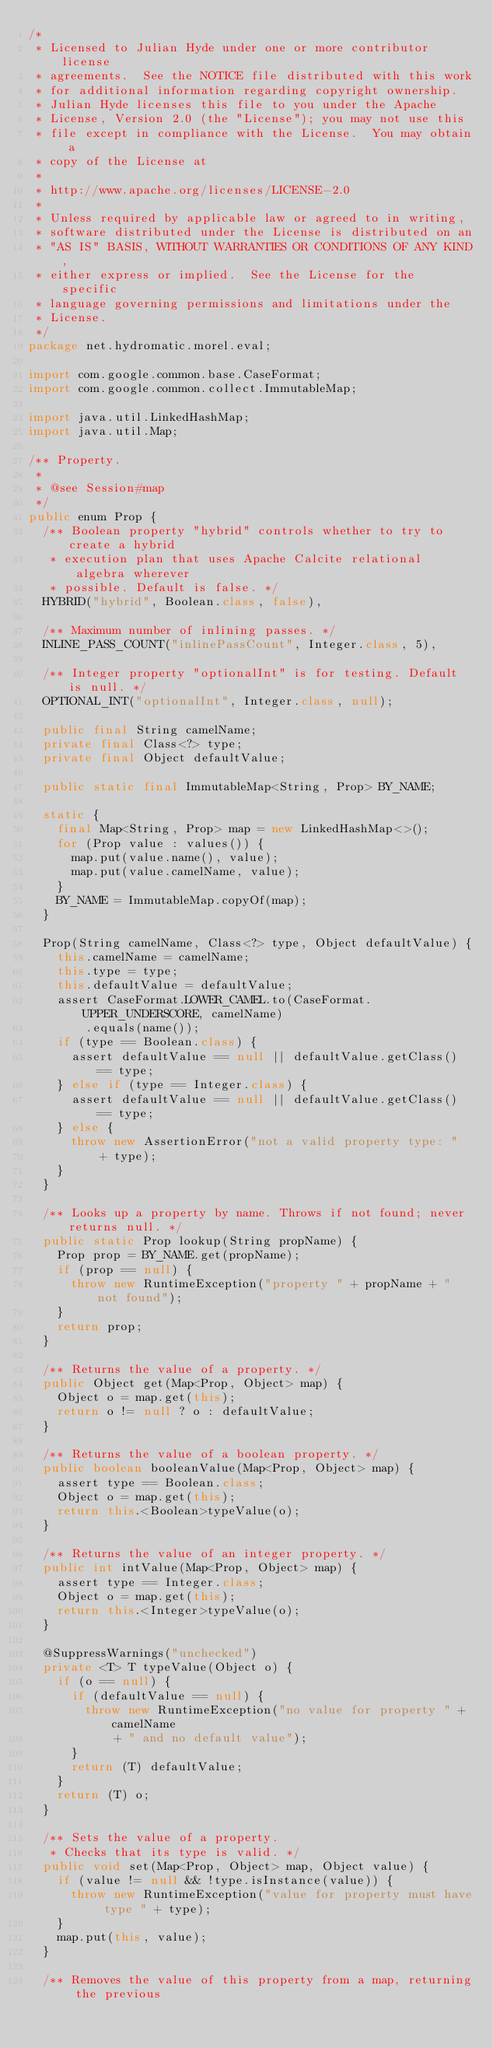<code> <loc_0><loc_0><loc_500><loc_500><_Java_>/*
 * Licensed to Julian Hyde under one or more contributor license
 * agreements.  See the NOTICE file distributed with this work
 * for additional information regarding copyright ownership.
 * Julian Hyde licenses this file to you under the Apache
 * License, Version 2.0 (the "License"); you may not use this
 * file except in compliance with the License.  You may obtain a
 * copy of the License at
 *
 * http://www.apache.org/licenses/LICENSE-2.0
 *
 * Unless required by applicable law or agreed to in writing,
 * software distributed under the License is distributed on an
 * "AS IS" BASIS, WITHOUT WARRANTIES OR CONDITIONS OF ANY KIND,
 * either express or implied.  See the License for the specific
 * language governing permissions and limitations under the
 * License.
 */
package net.hydromatic.morel.eval;

import com.google.common.base.CaseFormat;
import com.google.common.collect.ImmutableMap;

import java.util.LinkedHashMap;
import java.util.Map;

/** Property.
 *
 * @see Session#map
 */
public enum Prop {
  /** Boolean property "hybrid" controls whether to try to create a hybrid
   * execution plan that uses Apache Calcite relational algebra wherever
   * possible. Default is false. */
  HYBRID("hybrid", Boolean.class, false),

  /** Maximum number of inlining passes. */
  INLINE_PASS_COUNT("inlinePassCount", Integer.class, 5),

  /** Integer property "optionalInt" is for testing. Default is null. */
  OPTIONAL_INT("optionalInt", Integer.class, null);

  public final String camelName;
  private final Class<?> type;
  private final Object defaultValue;

  public static final ImmutableMap<String, Prop> BY_NAME;

  static {
    final Map<String, Prop> map = new LinkedHashMap<>();
    for (Prop value : values()) {
      map.put(value.name(), value);
      map.put(value.camelName, value);
    }
    BY_NAME = ImmutableMap.copyOf(map);
  }

  Prop(String camelName, Class<?> type, Object defaultValue) {
    this.camelName = camelName;
    this.type = type;
    this.defaultValue = defaultValue;
    assert CaseFormat.LOWER_CAMEL.to(CaseFormat.UPPER_UNDERSCORE, camelName)
        .equals(name());
    if (type == Boolean.class) {
      assert defaultValue == null || defaultValue.getClass() == type;
    } else if (type == Integer.class) {
      assert defaultValue == null || defaultValue.getClass() == type;
    } else {
      throw new AssertionError("not a valid property type: "
          + type);
    }
  }

  /** Looks up a property by name. Throws if not found; never returns null. */
  public static Prop lookup(String propName) {
    Prop prop = BY_NAME.get(propName);
    if (prop == null) {
      throw new RuntimeException("property " + propName + " not found");
    }
    return prop;
  }

  /** Returns the value of a property. */
  public Object get(Map<Prop, Object> map) {
    Object o = map.get(this);
    return o != null ? o : defaultValue;
  }

  /** Returns the value of a boolean property. */
  public boolean booleanValue(Map<Prop, Object> map) {
    assert type == Boolean.class;
    Object o = map.get(this);
    return this.<Boolean>typeValue(o);
  }

  /** Returns the value of an integer property. */
  public int intValue(Map<Prop, Object> map) {
    assert type == Integer.class;
    Object o = map.get(this);
    return this.<Integer>typeValue(o);
  }

  @SuppressWarnings("unchecked")
  private <T> T typeValue(Object o) {
    if (o == null) {
      if (defaultValue == null) {
        throw new RuntimeException("no value for property " + camelName
            + " and no default value");
      }
      return (T) defaultValue;
    }
    return (T) o;
  }

  /** Sets the value of a property.
   * Checks that its type is valid. */
  public void set(Map<Prop, Object> map, Object value) {
    if (value != null && !type.isInstance(value)) {
      throw new RuntimeException("value for property must have type " + type);
    }
    map.put(this, value);
  }

  /** Removes the value of this property from a map, returning the previous</code> 